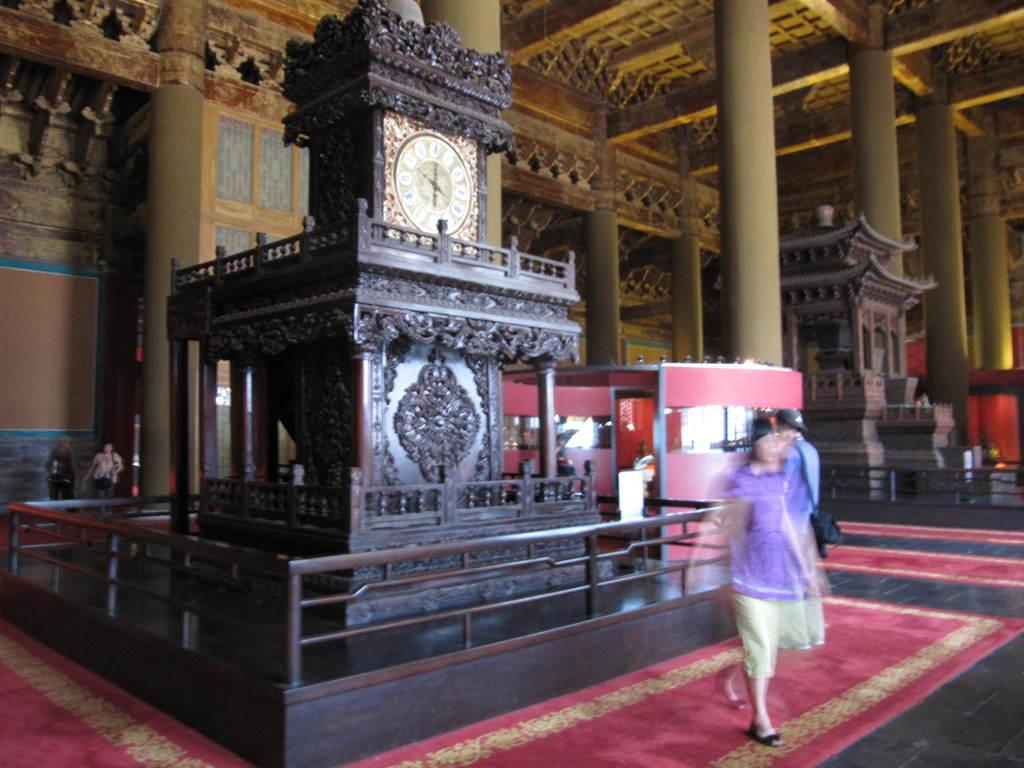What can be seen in the image involving people? There are people standing in the image. What type of structural elements are present in the image? There are iron rods and pillars in the image. What time-related object is visible in the image? There is a clock in the image. Can you describe any other objects in the image? There are some other objects in the image, but their specific details are not mentioned in the provided facts. Are there any horses visible in the image? No, there are no horses present in the image. What type of furniture can be seen in the image? There is no furniture mentioned or visible in the image. 